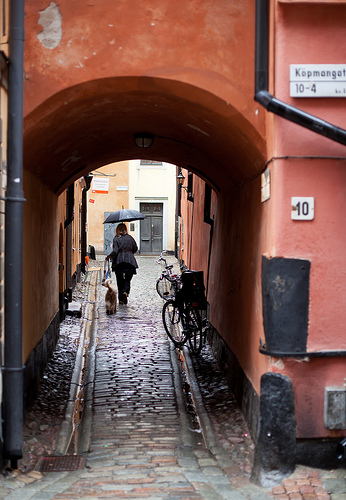<image>
Is there a women to the left of the cycle? Yes. From this viewpoint, the women is positioned to the left side relative to the cycle. Is the building behind the dog? Yes. From this viewpoint, the building is positioned behind the dog, with the dog partially or fully occluding the building. Where is the person in relation to the umbrella? Is it in front of the umbrella? No. The person is not in front of the umbrella. The spatial positioning shows a different relationship between these objects. 